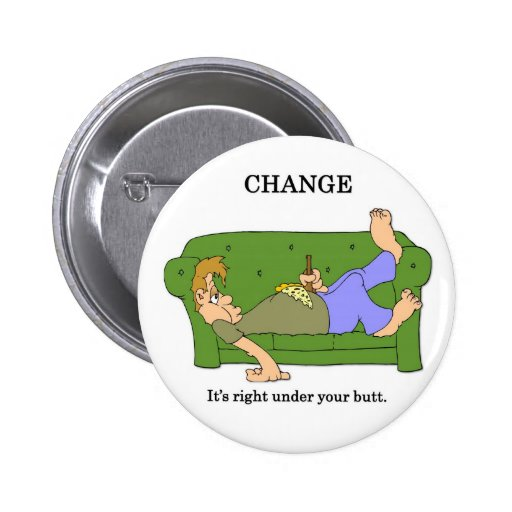Considering the visual pun presented in the image, what is the dual meaning of "CHANGE" as depicted, and how does the design use visual elements to communicate this play on words? The dual meaning of the word 'CHANGE' in the image plays on both its literal and metaphorical interpretations. Literally, 'change' refers to the coins that might be found under the couch where the person is lazily lying down. Metaphorically, it symbolizes the idea that significant changes in life or circumstances can begin from where one currently is, even from a state of inactivity or rest. The visual pun is effectively communicated through the design where two relaxed individuals are depicted on a couch—common locations for loose coins. This humorous take not only suggests finding literal change (coins) physically under them but also implies that potential for initiating life changes is within their immediate grasp, underscoring the motivational message that change starts from within and requires just a small effort. 